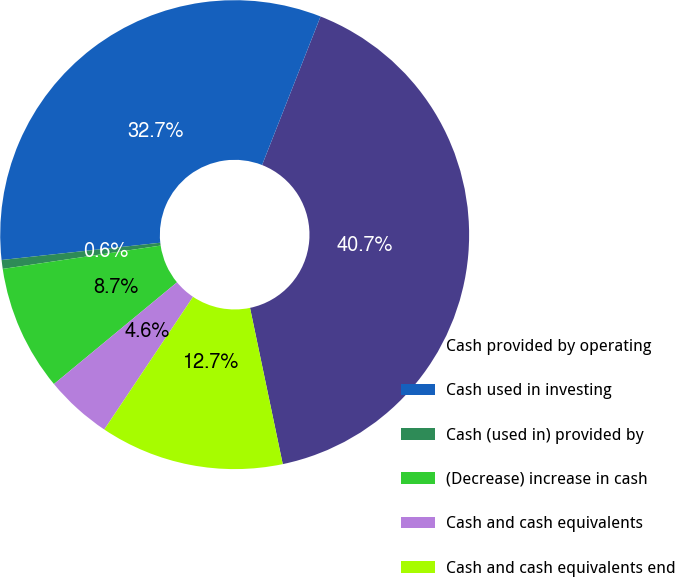Convert chart. <chart><loc_0><loc_0><loc_500><loc_500><pie_chart><fcel>Cash provided by operating<fcel>Cash used in investing<fcel>Cash (used in) provided by<fcel>(Decrease) increase in cash<fcel>Cash and cash equivalents<fcel>Cash and cash equivalents end<nl><fcel>40.74%<fcel>32.69%<fcel>0.61%<fcel>8.66%<fcel>4.62%<fcel>12.67%<nl></chart> 